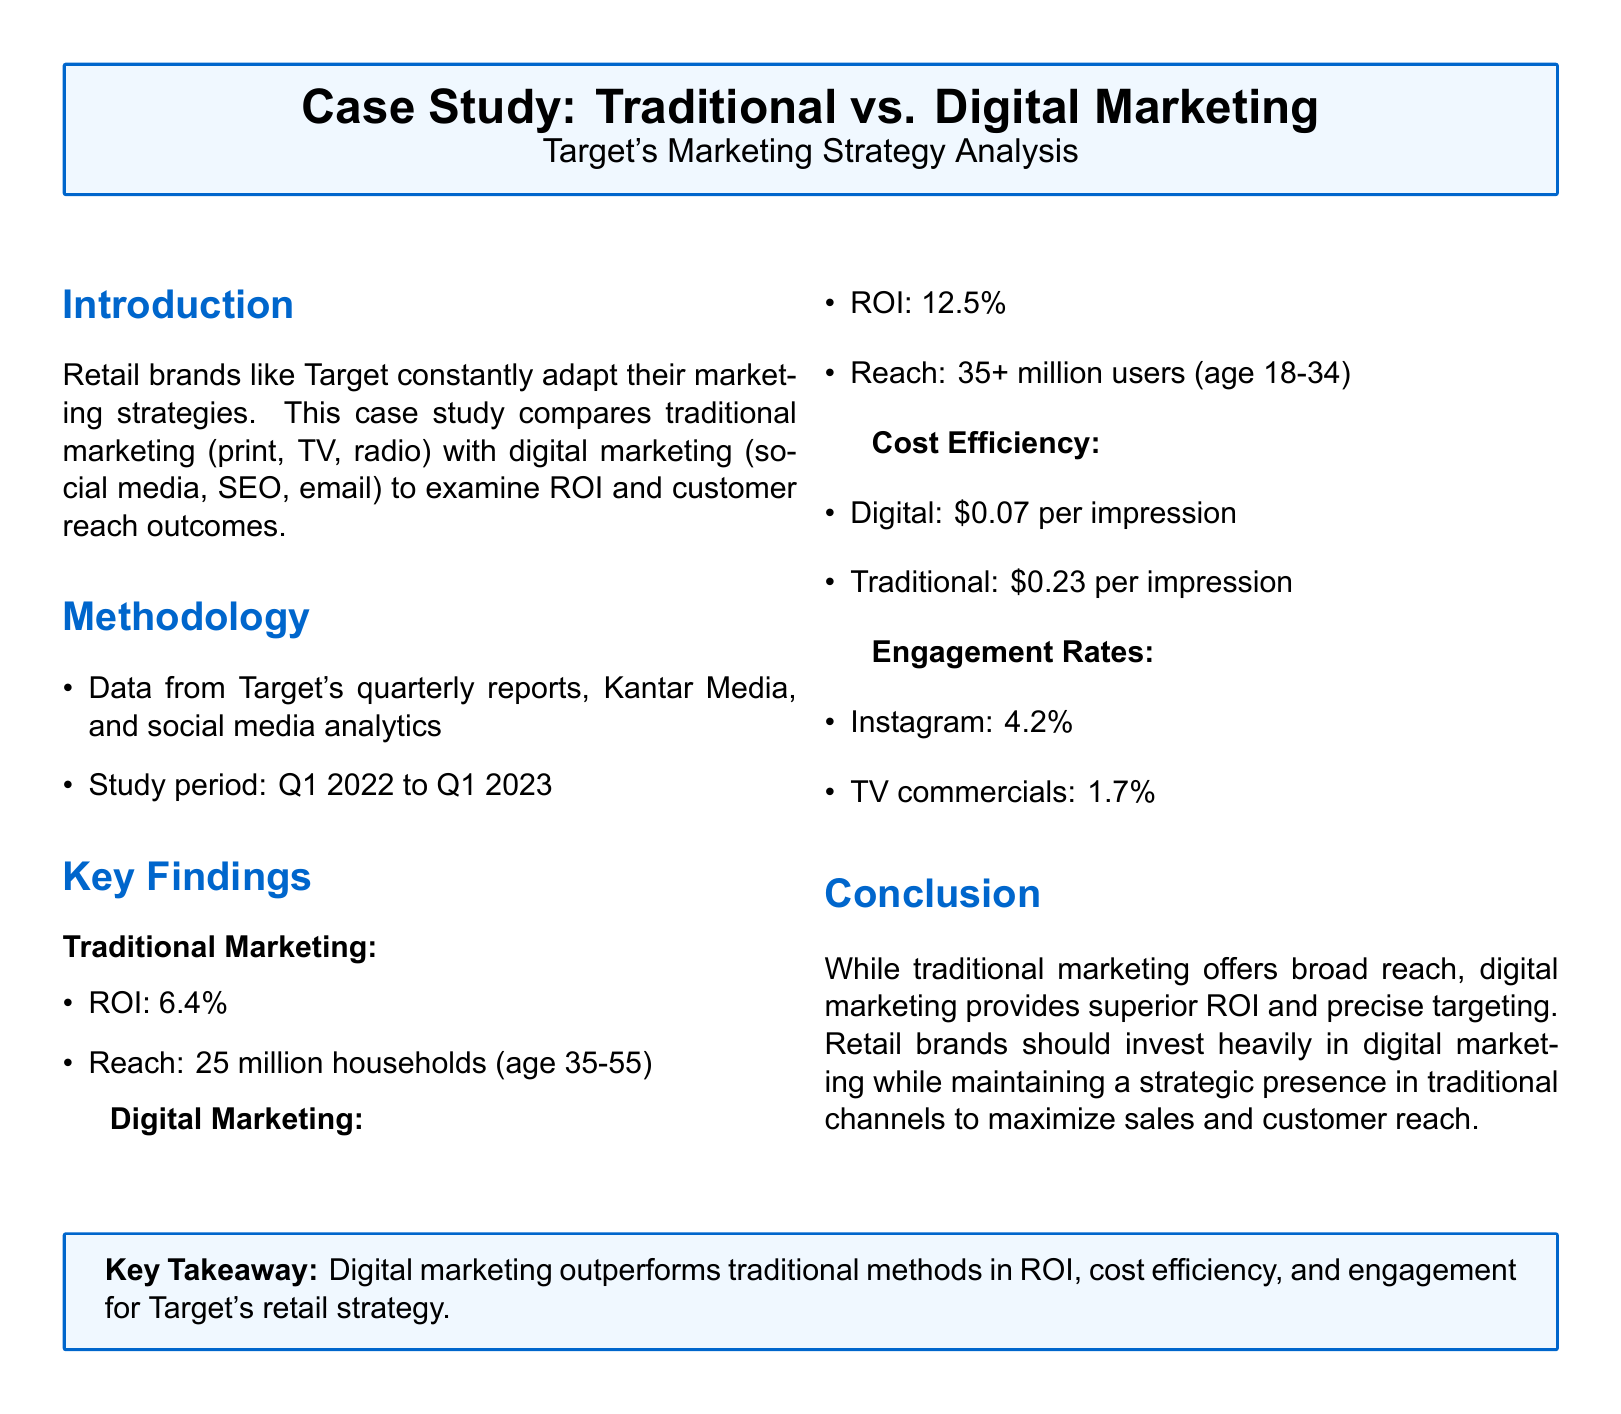what is the ROI for traditional marketing? The ROI for traditional marketing is specifically stated in the document as 6.4%.
Answer: 6.4% what is the reach for digital marketing? The reach for digital marketing is mentioned as over 35 million users, particularly in the age group of 18-34.
Answer: 35+ million users what is the cost per impression for traditional marketing? The document indicates that the cost per impression for traditional marketing is $0.23.
Answer: $0.23 which demographic does traditional marketing primarily target? The document states that traditional marketing primarily targets households with individuals aged 35-55.
Answer: age 35-55 what is the engagement rate for Instagram? The engagement rate for Instagram is specifically noted as 4.2%.
Answer: 4.2% which marketing method shows superior ROI? Based on the findings, digital marketing clearly shows superior ROI compared to traditional marketing.
Answer: digital marketing how much does digital marketing cost per impression? The cost per impression for digital marketing is stated as $0.07 in the document.
Answer: $0.07 what is a key takeaway from the case study? The key takeaway emphasizes that digital marketing outperforms traditional methods in several aspects for Target's retail strategy.
Answer: Digital marketing outperforms traditional methods what is the total engagement rate for TV commercials? The engagement rate for TV commercials is mentioned in the document as 1.7%.
Answer: 1.7% which years does the study period cover? The study period is from Q1 2022 to Q1 2023, as detailed in the methodology section.
Answer: Q1 2022 to Q1 2023 